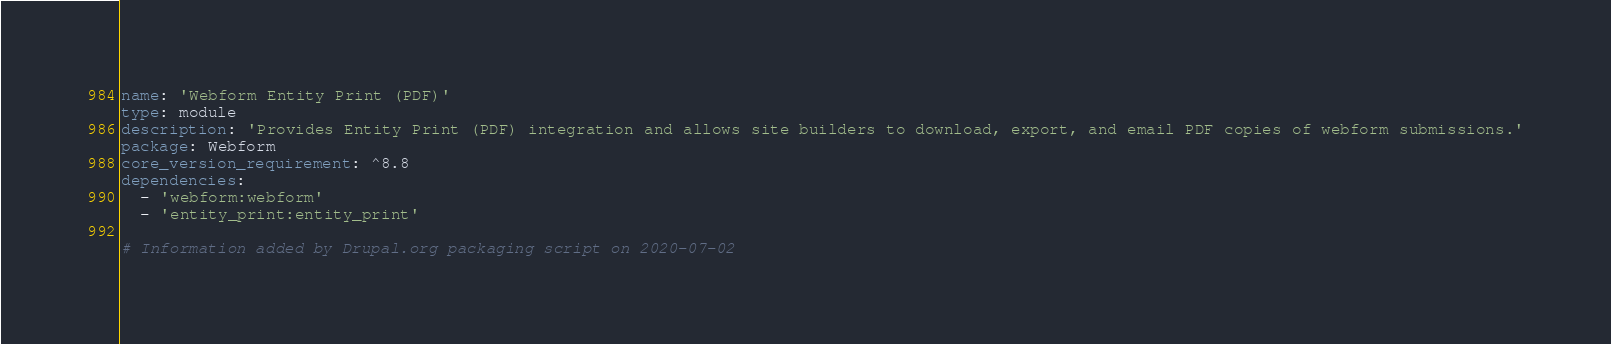Convert code to text. <code><loc_0><loc_0><loc_500><loc_500><_YAML_>name: 'Webform Entity Print (PDF)'
type: module
description: 'Provides Entity Print (PDF) integration and allows site builders to download, export, and email PDF copies of webform submissions.'
package: Webform
core_version_requirement: ^8.8
dependencies:
  - 'webform:webform'
  - 'entity_print:entity_print'

# Information added by Drupal.org packaging script on 2020-07-02</code> 